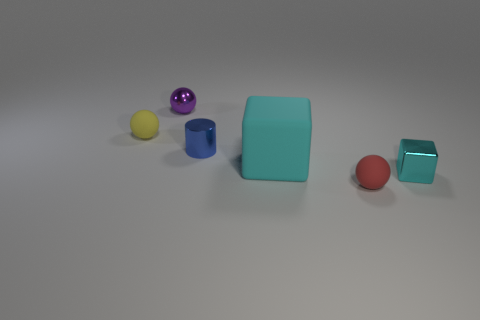Subtract all yellow spheres. How many spheres are left? 2 Subtract all yellow balls. How many balls are left? 2 Add 4 big cubes. How many objects exist? 10 Subtract all blocks. How many objects are left? 4 Add 4 large cyan objects. How many large cyan objects exist? 5 Subtract 0 green blocks. How many objects are left? 6 Subtract 3 balls. How many balls are left? 0 Subtract all purple spheres. Subtract all purple cubes. How many spheres are left? 2 Subtract all blue spheres. How many cyan cylinders are left? 0 Subtract all small red objects. Subtract all large green metal objects. How many objects are left? 5 